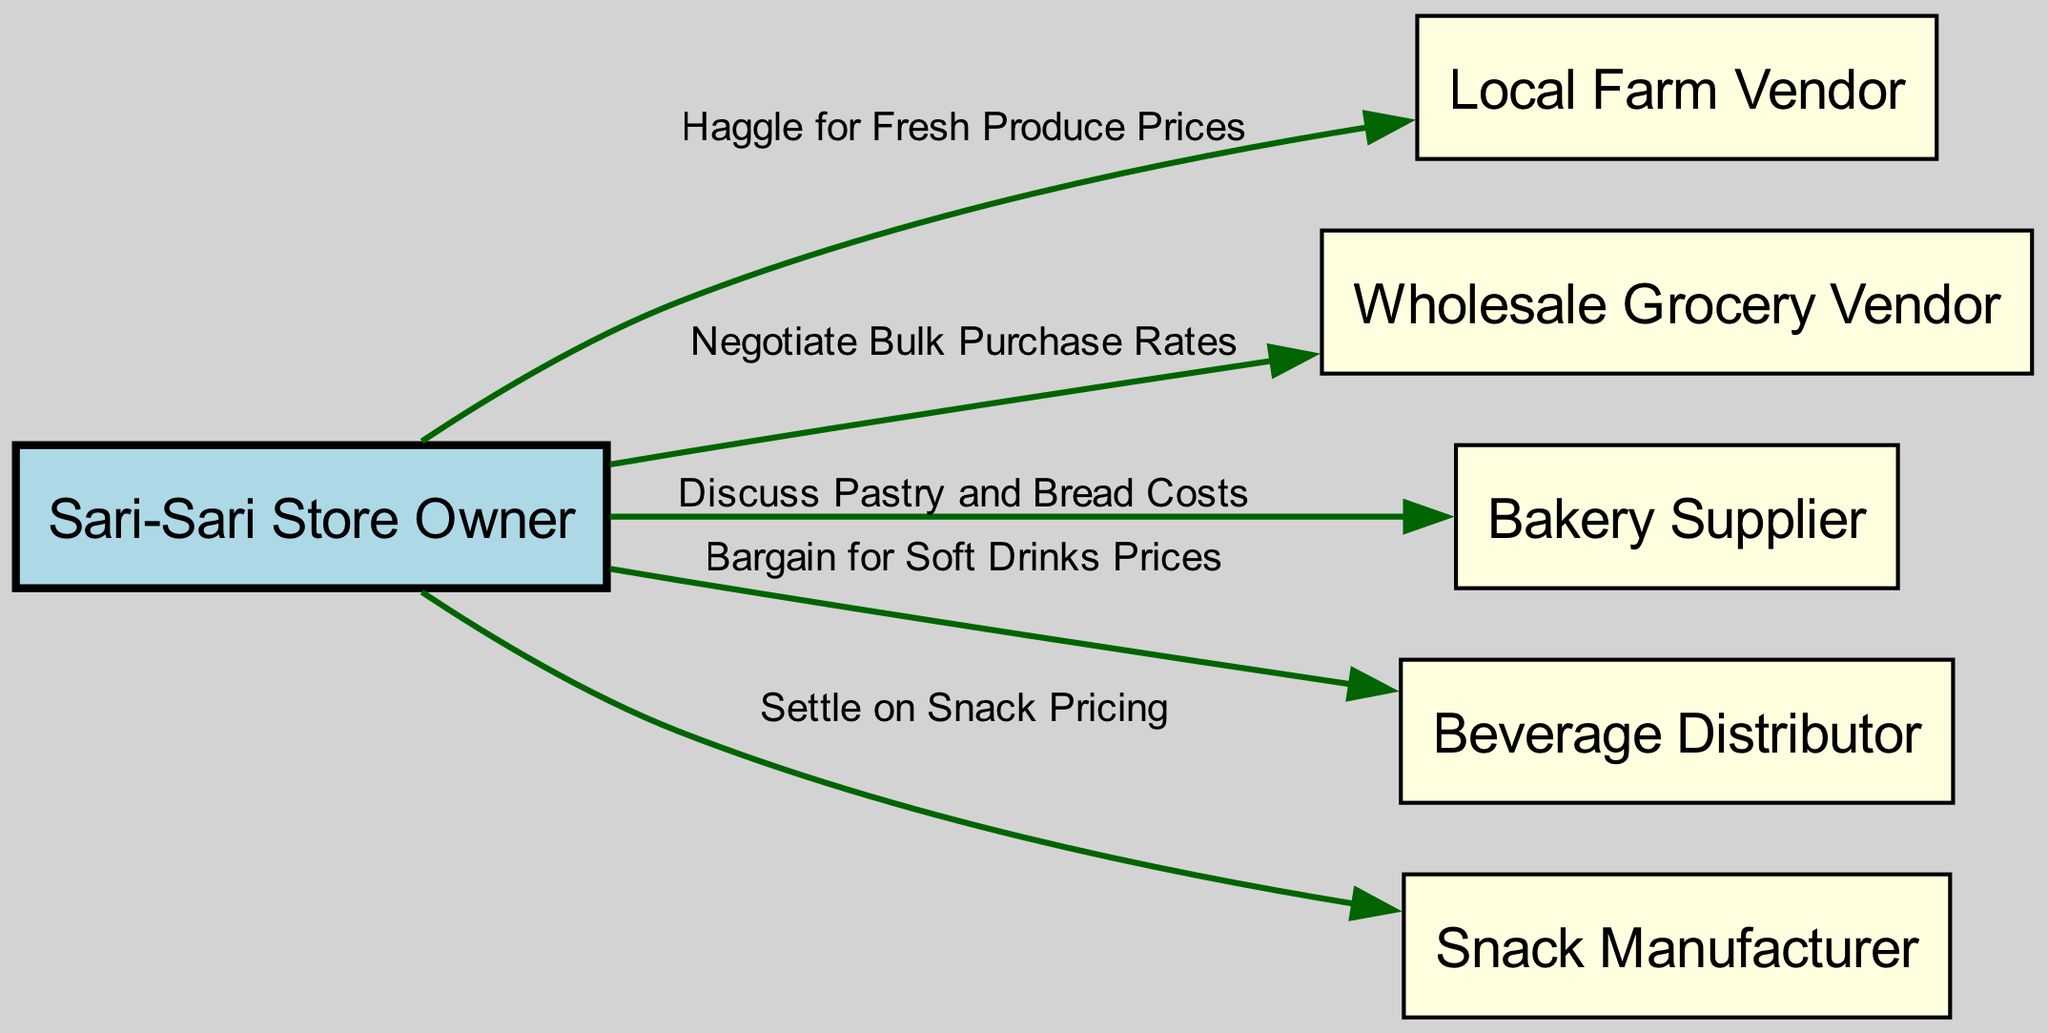What is the label of the node representing the store owner? The node labeled as "Sari-Sari Store Owner" represents the store owner. This information is found directly in the node descriptions of the diagram.
Answer: Sari-Sari Store Owner How many vendors are there in the diagram? By counting the nodes that represent vendors, we find a total of five vendor nodes: Local Farm Vendor, Wholesale Grocery Vendor, Bakery Supplier, Beverage Distributor, and Snack Manufacturer.
Answer: 5 Which vendor is associated with negotiating bulk purchase rates? The edge labeled "Negotiate Bulk Purchase Rates" connects the "Sari-Sari Store Owner" node to the "Wholesale Grocery Vendor" node. Thus, the vendor associated with this negotiation is the Wholesale Grocery Vendor.
Answer: Wholesale Grocery Vendor What type of pricing interaction is shown between the store owner and the beverage distributor? The edge labeled "Bargain for Soft Drinks Prices" indicates the interaction type between the store owner and the beverage distributor, which suggests that the negotiation focuses on the prices of soft drinks.
Answer: Bargain for Soft Drinks Prices Which vendor does the store owner haggle with for fresh produce prices? The edge labeled "Haggle for Fresh Produce Prices" directly connects the store owner node to the local farm vendor node, indicating that this haggling occurs specifically with the Local Farm Vendor.
Answer: Local Farm Vendor Which type of vendor is involved in discussing pastry and bread costs? The label for the edge connecting the store owner to the vendor clearly states "Discuss Pastry and Bread Costs," which indicates this discussion takes place with the Bakery Supplier
Answer: Bakery Supplier What flow direction is used in the diagram? The flow is represented as a directed graph with arrows indicating interactions moving from the Sari-Sari Store Owner to various vendors, showing a left-to-right orientation that implies the owner reaching out to the vendors for negotiations.
Answer: Left to Right Which vendor does the store owner settle on snack pricing with? The label on the edge connecting the store owner to the snack manufacturer shows the interaction "Settle on Snack Pricing," which reveals that this negotiation occurs specifically with the Snack Manufacturer.
Answer: Snack Manufacturer What is the color of the nodes representing the vendors? All vendor nodes are filled with light yellow color according to the node styles defined in the diagram generation code, indicating a consistent visual cue for vendor representation.
Answer: Light Yellow 